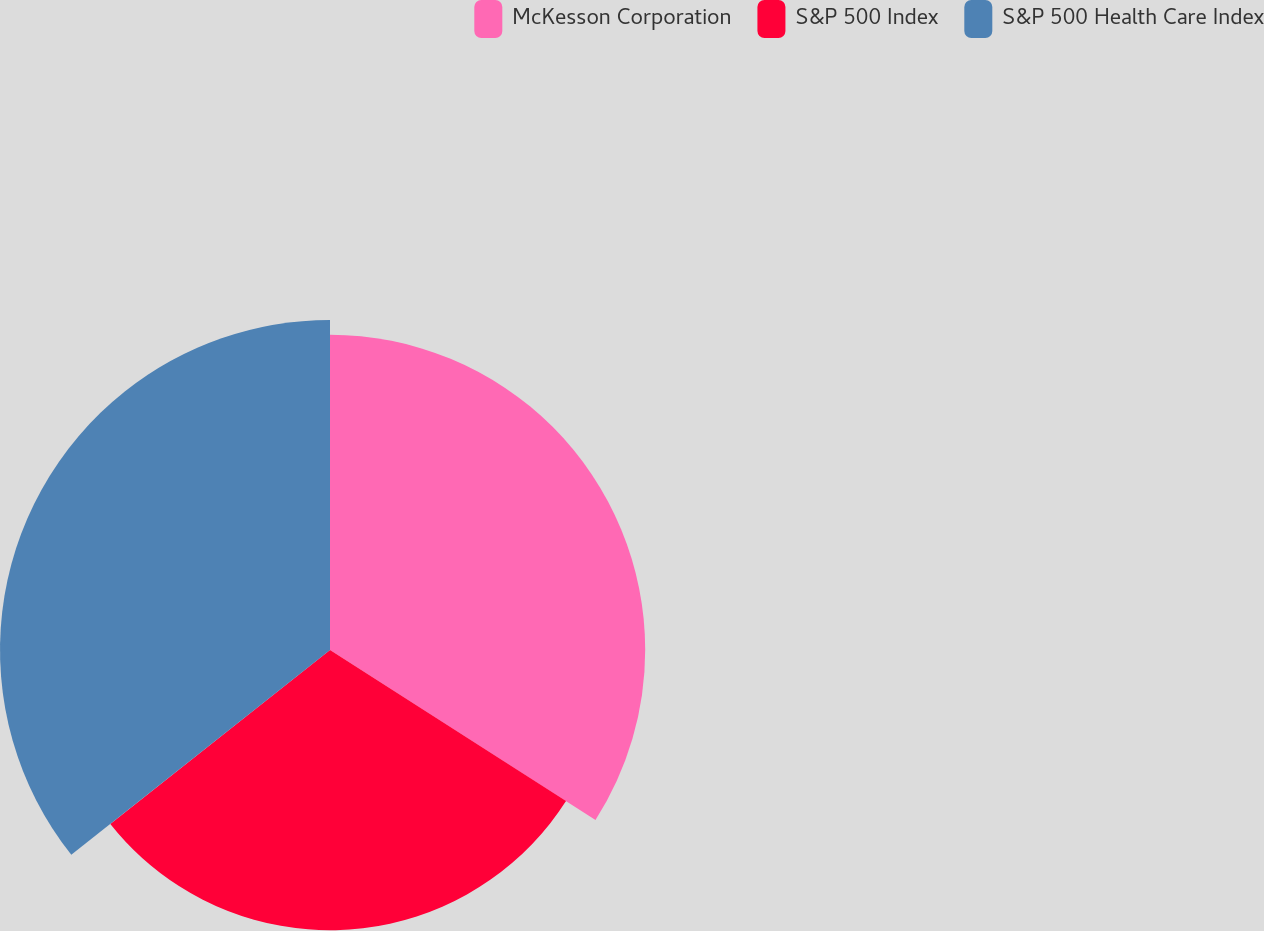Convert chart to OTSL. <chart><loc_0><loc_0><loc_500><loc_500><pie_chart><fcel>McKesson Corporation<fcel>S&P 500 Index<fcel>S&P 500 Health Care Index<nl><fcel>34.06%<fcel>30.28%<fcel>35.66%<nl></chart> 